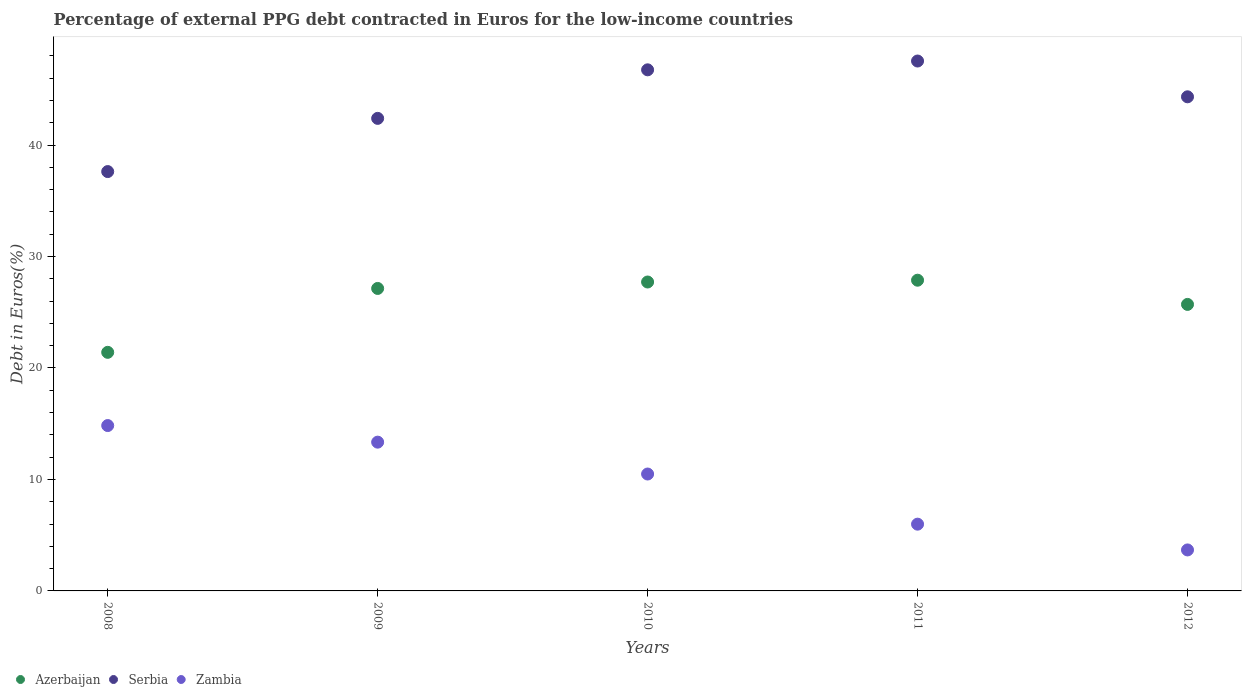Is the number of dotlines equal to the number of legend labels?
Your answer should be compact. Yes. What is the percentage of external PPG debt contracted in Euros in Zambia in 2011?
Your answer should be very brief. 5.99. Across all years, what is the maximum percentage of external PPG debt contracted in Euros in Azerbaijan?
Your answer should be very brief. 27.87. Across all years, what is the minimum percentage of external PPG debt contracted in Euros in Azerbaijan?
Give a very brief answer. 21.4. What is the total percentage of external PPG debt contracted in Euros in Zambia in the graph?
Your response must be concise. 48.33. What is the difference between the percentage of external PPG debt contracted in Euros in Azerbaijan in 2009 and that in 2010?
Provide a succinct answer. -0.58. What is the difference between the percentage of external PPG debt contracted in Euros in Azerbaijan in 2011 and the percentage of external PPG debt contracted in Euros in Serbia in 2009?
Your answer should be very brief. -14.52. What is the average percentage of external PPG debt contracted in Euros in Azerbaijan per year?
Your response must be concise. 25.96. In the year 2012, what is the difference between the percentage of external PPG debt contracted in Euros in Zambia and percentage of external PPG debt contracted in Euros in Serbia?
Your answer should be very brief. -40.65. In how many years, is the percentage of external PPG debt contracted in Euros in Zambia greater than 6 %?
Give a very brief answer. 3. What is the ratio of the percentage of external PPG debt contracted in Euros in Serbia in 2008 to that in 2010?
Offer a terse response. 0.8. What is the difference between the highest and the second highest percentage of external PPG debt contracted in Euros in Zambia?
Make the answer very short. 1.49. What is the difference between the highest and the lowest percentage of external PPG debt contracted in Euros in Azerbaijan?
Ensure brevity in your answer.  6.47. In how many years, is the percentage of external PPG debt contracted in Euros in Zambia greater than the average percentage of external PPG debt contracted in Euros in Zambia taken over all years?
Your answer should be very brief. 3. Is it the case that in every year, the sum of the percentage of external PPG debt contracted in Euros in Zambia and percentage of external PPG debt contracted in Euros in Azerbaijan  is greater than the percentage of external PPG debt contracted in Euros in Serbia?
Keep it short and to the point. No. Does the percentage of external PPG debt contracted in Euros in Azerbaijan monotonically increase over the years?
Offer a very short reply. No. How many dotlines are there?
Offer a very short reply. 3. How many years are there in the graph?
Ensure brevity in your answer.  5. What is the difference between two consecutive major ticks on the Y-axis?
Give a very brief answer. 10. How are the legend labels stacked?
Offer a very short reply. Horizontal. What is the title of the graph?
Provide a short and direct response. Percentage of external PPG debt contracted in Euros for the low-income countries. What is the label or title of the X-axis?
Ensure brevity in your answer.  Years. What is the label or title of the Y-axis?
Your answer should be very brief. Debt in Euros(%). What is the Debt in Euros(%) of Azerbaijan in 2008?
Offer a terse response. 21.4. What is the Debt in Euros(%) of Serbia in 2008?
Your answer should be compact. 37.62. What is the Debt in Euros(%) in Zambia in 2008?
Offer a very short reply. 14.83. What is the Debt in Euros(%) in Azerbaijan in 2009?
Provide a short and direct response. 27.13. What is the Debt in Euros(%) of Serbia in 2009?
Your response must be concise. 42.39. What is the Debt in Euros(%) of Zambia in 2009?
Offer a very short reply. 13.35. What is the Debt in Euros(%) in Azerbaijan in 2010?
Make the answer very short. 27.71. What is the Debt in Euros(%) in Serbia in 2010?
Offer a very short reply. 46.74. What is the Debt in Euros(%) in Zambia in 2010?
Offer a terse response. 10.49. What is the Debt in Euros(%) of Azerbaijan in 2011?
Ensure brevity in your answer.  27.87. What is the Debt in Euros(%) of Serbia in 2011?
Your answer should be compact. 47.53. What is the Debt in Euros(%) in Zambia in 2011?
Your answer should be very brief. 5.99. What is the Debt in Euros(%) in Azerbaijan in 2012?
Provide a short and direct response. 25.7. What is the Debt in Euros(%) in Serbia in 2012?
Your response must be concise. 44.32. What is the Debt in Euros(%) in Zambia in 2012?
Give a very brief answer. 3.68. Across all years, what is the maximum Debt in Euros(%) in Azerbaijan?
Your answer should be compact. 27.87. Across all years, what is the maximum Debt in Euros(%) in Serbia?
Your response must be concise. 47.53. Across all years, what is the maximum Debt in Euros(%) of Zambia?
Your response must be concise. 14.83. Across all years, what is the minimum Debt in Euros(%) of Azerbaijan?
Ensure brevity in your answer.  21.4. Across all years, what is the minimum Debt in Euros(%) in Serbia?
Offer a very short reply. 37.62. Across all years, what is the minimum Debt in Euros(%) of Zambia?
Ensure brevity in your answer.  3.68. What is the total Debt in Euros(%) of Azerbaijan in the graph?
Offer a terse response. 129.82. What is the total Debt in Euros(%) in Serbia in the graph?
Make the answer very short. 218.61. What is the total Debt in Euros(%) of Zambia in the graph?
Your answer should be very brief. 48.33. What is the difference between the Debt in Euros(%) in Azerbaijan in 2008 and that in 2009?
Give a very brief answer. -5.73. What is the difference between the Debt in Euros(%) of Serbia in 2008 and that in 2009?
Your answer should be very brief. -4.77. What is the difference between the Debt in Euros(%) of Zambia in 2008 and that in 2009?
Your answer should be very brief. 1.49. What is the difference between the Debt in Euros(%) in Azerbaijan in 2008 and that in 2010?
Your answer should be very brief. -6.31. What is the difference between the Debt in Euros(%) of Serbia in 2008 and that in 2010?
Offer a very short reply. -9.13. What is the difference between the Debt in Euros(%) of Zambia in 2008 and that in 2010?
Keep it short and to the point. 4.35. What is the difference between the Debt in Euros(%) in Azerbaijan in 2008 and that in 2011?
Ensure brevity in your answer.  -6.47. What is the difference between the Debt in Euros(%) in Serbia in 2008 and that in 2011?
Make the answer very short. -9.92. What is the difference between the Debt in Euros(%) of Zambia in 2008 and that in 2011?
Offer a terse response. 8.85. What is the difference between the Debt in Euros(%) in Azerbaijan in 2008 and that in 2012?
Your answer should be very brief. -4.3. What is the difference between the Debt in Euros(%) in Serbia in 2008 and that in 2012?
Keep it short and to the point. -6.71. What is the difference between the Debt in Euros(%) of Zambia in 2008 and that in 2012?
Make the answer very short. 11.16. What is the difference between the Debt in Euros(%) of Azerbaijan in 2009 and that in 2010?
Make the answer very short. -0.58. What is the difference between the Debt in Euros(%) in Serbia in 2009 and that in 2010?
Ensure brevity in your answer.  -4.35. What is the difference between the Debt in Euros(%) in Zambia in 2009 and that in 2010?
Keep it short and to the point. 2.86. What is the difference between the Debt in Euros(%) in Azerbaijan in 2009 and that in 2011?
Keep it short and to the point. -0.74. What is the difference between the Debt in Euros(%) of Serbia in 2009 and that in 2011?
Ensure brevity in your answer.  -5.14. What is the difference between the Debt in Euros(%) of Zambia in 2009 and that in 2011?
Provide a succinct answer. 7.36. What is the difference between the Debt in Euros(%) of Azerbaijan in 2009 and that in 2012?
Your answer should be very brief. 1.43. What is the difference between the Debt in Euros(%) in Serbia in 2009 and that in 2012?
Offer a terse response. -1.93. What is the difference between the Debt in Euros(%) in Zambia in 2009 and that in 2012?
Provide a short and direct response. 9.67. What is the difference between the Debt in Euros(%) in Azerbaijan in 2010 and that in 2011?
Provide a short and direct response. -0.16. What is the difference between the Debt in Euros(%) of Serbia in 2010 and that in 2011?
Offer a terse response. -0.79. What is the difference between the Debt in Euros(%) of Zambia in 2010 and that in 2011?
Ensure brevity in your answer.  4.5. What is the difference between the Debt in Euros(%) in Azerbaijan in 2010 and that in 2012?
Provide a short and direct response. 2.01. What is the difference between the Debt in Euros(%) of Serbia in 2010 and that in 2012?
Your answer should be very brief. 2.42. What is the difference between the Debt in Euros(%) in Zambia in 2010 and that in 2012?
Your answer should be compact. 6.81. What is the difference between the Debt in Euros(%) in Azerbaijan in 2011 and that in 2012?
Give a very brief answer. 2.17. What is the difference between the Debt in Euros(%) in Serbia in 2011 and that in 2012?
Your answer should be compact. 3.21. What is the difference between the Debt in Euros(%) in Zambia in 2011 and that in 2012?
Provide a succinct answer. 2.31. What is the difference between the Debt in Euros(%) in Azerbaijan in 2008 and the Debt in Euros(%) in Serbia in 2009?
Provide a succinct answer. -20.99. What is the difference between the Debt in Euros(%) in Azerbaijan in 2008 and the Debt in Euros(%) in Zambia in 2009?
Your answer should be compact. 8.06. What is the difference between the Debt in Euros(%) of Serbia in 2008 and the Debt in Euros(%) of Zambia in 2009?
Offer a very short reply. 24.27. What is the difference between the Debt in Euros(%) of Azerbaijan in 2008 and the Debt in Euros(%) of Serbia in 2010?
Offer a terse response. -25.34. What is the difference between the Debt in Euros(%) of Azerbaijan in 2008 and the Debt in Euros(%) of Zambia in 2010?
Your answer should be very brief. 10.92. What is the difference between the Debt in Euros(%) of Serbia in 2008 and the Debt in Euros(%) of Zambia in 2010?
Give a very brief answer. 27.13. What is the difference between the Debt in Euros(%) of Azerbaijan in 2008 and the Debt in Euros(%) of Serbia in 2011?
Keep it short and to the point. -26.13. What is the difference between the Debt in Euros(%) in Azerbaijan in 2008 and the Debt in Euros(%) in Zambia in 2011?
Your response must be concise. 15.41. What is the difference between the Debt in Euros(%) in Serbia in 2008 and the Debt in Euros(%) in Zambia in 2011?
Your answer should be very brief. 31.63. What is the difference between the Debt in Euros(%) in Azerbaijan in 2008 and the Debt in Euros(%) in Serbia in 2012?
Offer a terse response. -22.92. What is the difference between the Debt in Euros(%) of Azerbaijan in 2008 and the Debt in Euros(%) of Zambia in 2012?
Make the answer very short. 17.73. What is the difference between the Debt in Euros(%) of Serbia in 2008 and the Debt in Euros(%) of Zambia in 2012?
Offer a terse response. 33.94. What is the difference between the Debt in Euros(%) of Azerbaijan in 2009 and the Debt in Euros(%) of Serbia in 2010?
Give a very brief answer. -19.61. What is the difference between the Debt in Euros(%) in Azerbaijan in 2009 and the Debt in Euros(%) in Zambia in 2010?
Provide a succinct answer. 16.65. What is the difference between the Debt in Euros(%) in Serbia in 2009 and the Debt in Euros(%) in Zambia in 2010?
Give a very brief answer. 31.9. What is the difference between the Debt in Euros(%) of Azerbaijan in 2009 and the Debt in Euros(%) of Serbia in 2011?
Your answer should be very brief. -20.4. What is the difference between the Debt in Euros(%) of Azerbaijan in 2009 and the Debt in Euros(%) of Zambia in 2011?
Keep it short and to the point. 21.14. What is the difference between the Debt in Euros(%) of Serbia in 2009 and the Debt in Euros(%) of Zambia in 2011?
Keep it short and to the point. 36.4. What is the difference between the Debt in Euros(%) of Azerbaijan in 2009 and the Debt in Euros(%) of Serbia in 2012?
Keep it short and to the point. -17.19. What is the difference between the Debt in Euros(%) in Azerbaijan in 2009 and the Debt in Euros(%) in Zambia in 2012?
Offer a terse response. 23.46. What is the difference between the Debt in Euros(%) in Serbia in 2009 and the Debt in Euros(%) in Zambia in 2012?
Make the answer very short. 38.71. What is the difference between the Debt in Euros(%) of Azerbaijan in 2010 and the Debt in Euros(%) of Serbia in 2011?
Make the answer very short. -19.82. What is the difference between the Debt in Euros(%) in Azerbaijan in 2010 and the Debt in Euros(%) in Zambia in 2011?
Ensure brevity in your answer.  21.72. What is the difference between the Debt in Euros(%) in Serbia in 2010 and the Debt in Euros(%) in Zambia in 2011?
Your answer should be very brief. 40.76. What is the difference between the Debt in Euros(%) in Azerbaijan in 2010 and the Debt in Euros(%) in Serbia in 2012?
Keep it short and to the point. -16.61. What is the difference between the Debt in Euros(%) in Azerbaijan in 2010 and the Debt in Euros(%) in Zambia in 2012?
Your response must be concise. 24.03. What is the difference between the Debt in Euros(%) of Serbia in 2010 and the Debt in Euros(%) of Zambia in 2012?
Your answer should be very brief. 43.07. What is the difference between the Debt in Euros(%) of Azerbaijan in 2011 and the Debt in Euros(%) of Serbia in 2012?
Provide a succinct answer. -16.45. What is the difference between the Debt in Euros(%) in Azerbaijan in 2011 and the Debt in Euros(%) in Zambia in 2012?
Give a very brief answer. 24.2. What is the difference between the Debt in Euros(%) in Serbia in 2011 and the Debt in Euros(%) in Zambia in 2012?
Offer a terse response. 43.86. What is the average Debt in Euros(%) in Azerbaijan per year?
Your answer should be very brief. 25.96. What is the average Debt in Euros(%) in Serbia per year?
Your answer should be very brief. 43.72. What is the average Debt in Euros(%) in Zambia per year?
Offer a terse response. 9.67. In the year 2008, what is the difference between the Debt in Euros(%) in Azerbaijan and Debt in Euros(%) in Serbia?
Ensure brevity in your answer.  -16.21. In the year 2008, what is the difference between the Debt in Euros(%) in Azerbaijan and Debt in Euros(%) in Zambia?
Keep it short and to the point. 6.57. In the year 2008, what is the difference between the Debt in Euros(%) in Serbia and Debt in Euros(%) in Zambia?
Provide a succinct answer. 22.78. In the year 2009, what is the difference between the Debt in Euros(%) in Azerbaijan and Debt in Euros(%) in Serbia?
Provide a short and direct response. -15.26. In the year 2009, what is the difference between the Debt in Euros(%) of Azerbaijan and Debt in Euros(%) of Zambia?
Offer a terse response. 13.79. In the year 2009, what is the difference between the Debt in Euros(%) of Serbia and Debt in Euros(%) of Zambia?
Offer a very short reply. 29.04. In the year 2010, what is the difference between the Debt in Euros(%) of Azerbaijan and Debt in Euros(%) of Serbia?
Provide a short and direct response. -19.03. In the year 2010, what is the difference between the Debt in Euros(%) in Azerbaijan and Debt in Euros(%) in Zambia?
Your answer should be very brief. 17.22. In the year 2010, what is the difference between the Debt in Euros(%) in Serbia and Debt in Euros(%) in Zambia?
Your response must be concise. 36.26. In the year 2011, what is the difference between the Debt in Euros(%) in Azerbaijan and Debt in Euros(%) in Serbia?
Your answer should be very brief. -19.66. In the year 2011, what is the difference between the Debt in Euros(%) in Azerbaijan and Debt in Euros(%) in Zambia?
Offer a very short reply. 21.88. In the year 2011, what is the difference between the Debt in Euros(%) in Serbia and Debt in Euros(%) in Zambia?
Your response must be concise. 41.55. In the year 2012, what is the difference between the Debt in Euros(%) in Azerbaijan and Debt in Euros(%) in Serbia?
Your answer should be compact. -18.62. In the year 2012, what is the difference between the Debt in Euros(%) in Azerbaijan and Debt in Euros(%) in Zambia?
Give a very brief answer. 22.02. In the year 2012, what is the difference between the Debt in Euros(%) in Serbia and Debt in Euros(%) in Zambia?
Make the answer very short. 40.65. What is the ratio of the Debt in Euros(%) in Azerbaijan in 2008 to that in 2009?
Your answer should be compact. 0.79. What is the ratio of the Debt in Euros(%) of Serbia in 2008 to that in 2009?
Keep it short and to the point. 0.89. What is the ratio of the Debt in Euros(%) in Zambia in 2008 to that in 2009?
Your answer should be very brief. 1.11. What is the ratio of the Debt in Euros(%) of Azerbaijan in 2008 to that in 2010?
Your answer should be very brief. 0.77. What is the ratio of the Debt in Euros(%) in Serbia in 2008 to that in 2010?
Ensure brevity in your answer.  0.8. What is the ratio of the Debt in Euros(%) of Zambia in 2008 to that in 2010?
Your response must be concise. 1.41. What is the ratio of the Debt in Euros(%) of Azerbaijan in 2008 to that in 2011?
Your response must be concise. 0.77. What is the ratio of the Debt in Euros(%) of Serbia in 2008 to that in 2011?
Give a very brief answer. 0.79. What is the ratio of the Debt in Euros(%) of Zambia in 2008 to that in 2011?
Offer a terse response. 2.48. What is the ratio of the Debt in Euros(%) in Azerbaijan in 2008 to that in 2012?
Offer a very short reply. 0.83. What is the ratio of the Debt in Euros(%) of Serbia in 2008 to that in 2012?
Your answer should be compact. 0.85. What is the ratio of the Debt in Euros(%) of Zambia in 2008 to that in 2012?
Your answer should be very brief. 4.03. What is the ratio of the Debt in Euros(%) in Azerbaijan in 2009 to that in 2010?
Offer a very short reply. 0.98. What is the ratio of the Debt in Euros(%) in Serbia in 2009 to that in 2010?
Offer a terse response. 0.91. What is the ratio of the Debt in Euros(%) of Zambia in 2009 to that in 2010?
Your response must be concise. 1.27. What is the ratio of the Debt in Euros(%) of Azerbaijan in 2009 to that in 2011?
Provide a short and direct response. 0.97. What is the ratio of the Debt in Euros(%) in Serbia in 2009 to that in 2011?
Give a very brief answer. 0.89. What is the ratio of the Debt in Euros(%) in Zambia in 2009 to that in 2011?
Keep it short and to the point. 2.23. What is the ratio of the Debt in Euros(%) in Azerbaijan in 2009 to that in 2012?
Provide a succinct answer. 1.06. What is the ratio of the Debt in Euros(%) in Serbia in 2009 to that in 2012?
Provide a short and direct response. 0.96. What is the ratio of the Debt in Euros(%) of Zambia in 2009 to that in 2012?
Make the answer very short. 3.63. What is the ratio of the Debt in Euros(%) of Serbia in 2010 to that in 2011?
Your answer should be very brief. 0.98. What is the ratio of the Debt in Euros(%) of Zambia in 2010 to that in 2011?
Your answer should be compact. 1.75. What is the ratio of the Debt in Euros(%) in Azerbaijan in 2010 to that in 2012?
Your response must be concise. 1.08. What is the ratio of the Debt in Euros(%) of Serbia in 2010 to that in 2012?
Give a very brief answer. 1.05. What is the ratio of the Debt in Euros(%) in Zambia in 2010 to that in 2012?
Your response must be concise. 2.85. What is the ratio of the Debt in Euros(%) of Azerbaijan in 2011 to that in 2012?
Make the answer very short. 1.08. What is the ratio of the Debt in Euros(%) of Serbia in 2011 to that in 2012?
Provide a succinct answer. 1.07. What is the ratio of the Debt in Euros(%) in Zambia in 2011 to that in 2012?
Offer a terse response. 1.63. What is the difference between the highest and the second highest Debt in Euros(%) of Azerbaijan?
Your response must be concise. 0.16. What is the difference between the highest and the second highest Debt in Euros(%) of Serbia?
Keep it short and to the point. 0.79. What is the difference between the highest and the second highest Debt in Euros(%) in Zambia?
Offer a terse response. 1.49. What is the difference between the highest and the lowest Debt in Euros(%) of Azerbaijan?
Your response must be concise. 6.47. What is the difference between the highest and the lowest Debt in Euros(%) of Serbia?
Make the answer very short. 9.92. What is the difference between the highest and the lowest Debt in Euros(%) of Zambia?
Provide a short and direct response. 11.16. 